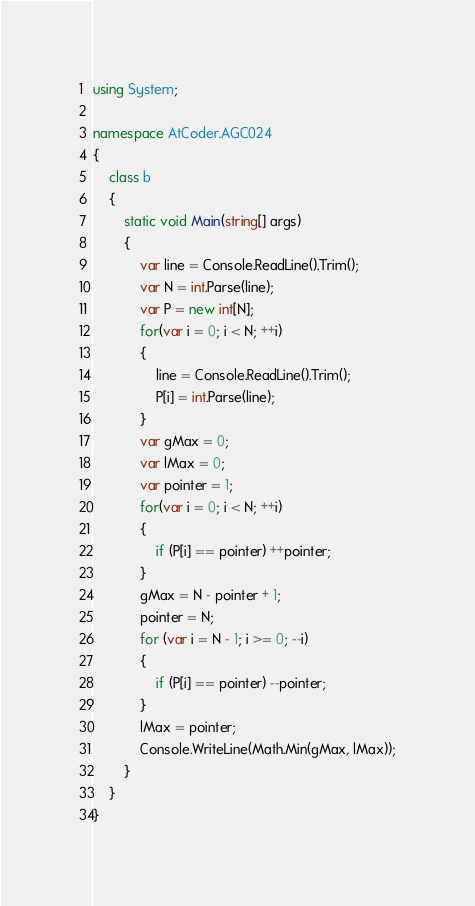Convert code to text. <code><loc_0><loc_0><loc_500><loc_500><_C#_>using System;

namespace AtCoder.AGC024
{
    class b
    {
        static void Main(string[] args)
        {
            var line = Console.ReadLine().Trim();
            var N = int.Parse(line);
            var P = new int[N];
            for(var i = 0; i < N; ++i)
            {
                line = Console.ReadLine().Trim();
                P[i] = int.Parse(line);
            }
            var gMax = 0;
            var lMax = 0;
            var pointer = 1;
            for(var i = 0; i < N; ++i)
            {
                if (P[i] == pointer) ++pointer;
            }
            gMax = N - pointer + 1;
            pointer = N;
            for (var i = N - 1; i >= 0; --i)
            {
                if (P[i] == pointer) --pointer;
            }
            lMax = pointer;
            Console.WriteLine(Math.Min(gMax, lMax));
        }
    }
}
</code> 